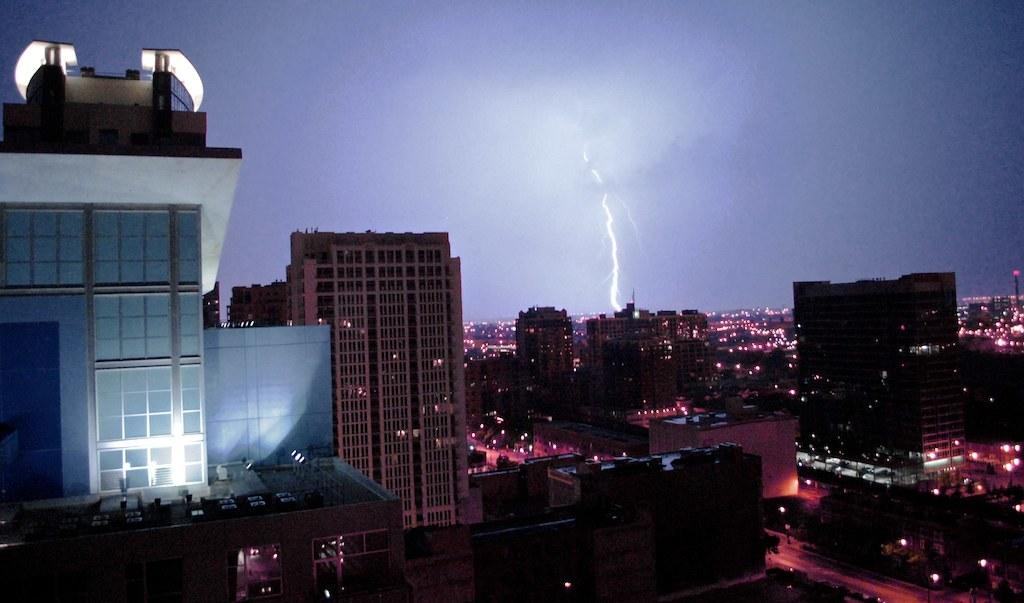What type of buildings are present in the image? The buildings in the image have glass windows. Can you describe the weather condition in the image? There is thunder and lightning visible in the distance. Where is the seat located in the image? There is no seat present in the image. What type of wire can be seen connecting the buildings? There is no wire connecting the buildings in the image. 